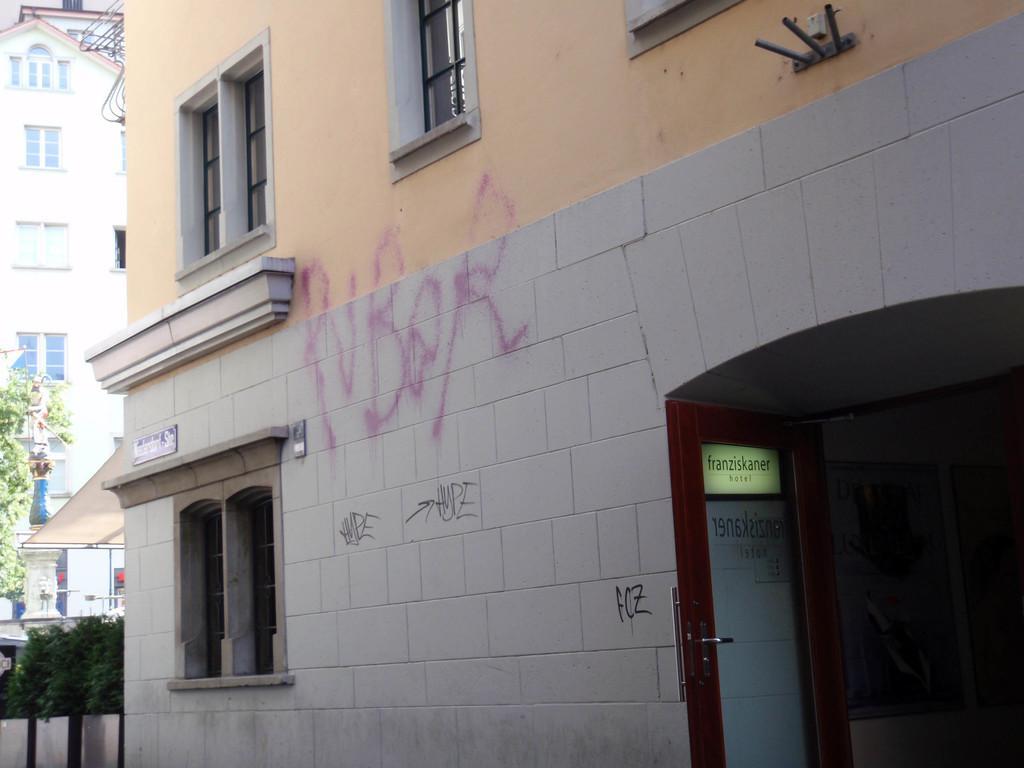Could you give a brief overview of what you see in this image? In this picture i can see buildings. On the right side i can see a door. On the left side i can see trees. 